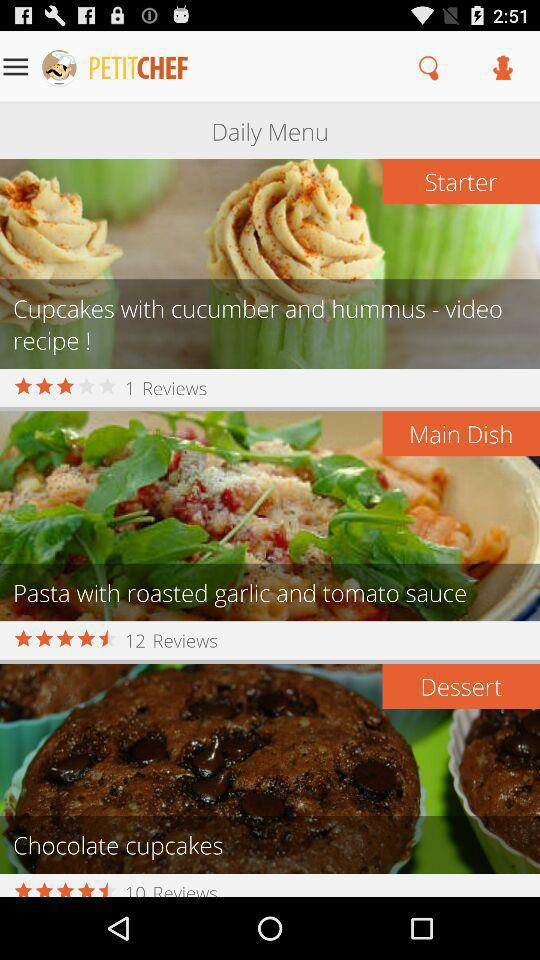How many reviews are there for the dessert dish? There are 10 reviews. 